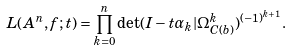Convert formula to latex. <formula><loc_0><loc_0><loc_500><loc_500>L ( { A } ^ { n } , f ; t ) = \prod _ { k = 0 } ^ { n } \det ( I - t \alpha _ { k } | \Omega _ { C ( b ) } ^ { k } ) ^ { ( - 1 ) ^ { k + 1 } } .</formula> 